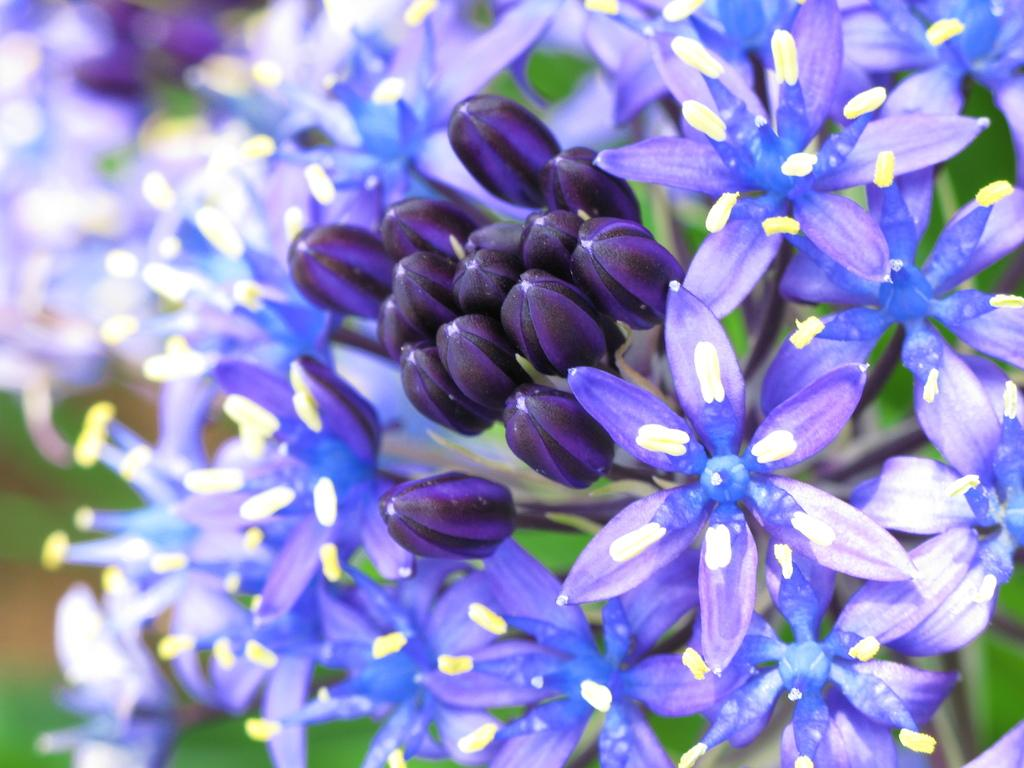What color are the flowers in the image? The flowers in the image are blue. What type of plant do the flowers belong to? The flowers are part of a plant. Can you describe the quality of the image on the left side? The left side of the image is slightly blurred. Where is the sink located in the image? There is no sink present in the image. What type of sticks can be seen in the image? There are no sticks present in the image. 